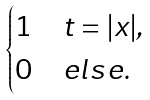<formula> <loc_0><loc_0><loc_500><loc_500>\begin{cases} 1 & t = | x | , \\ 0 & e l s e . \end{cases}</formula> 